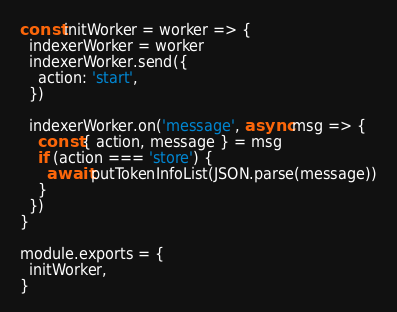Convert code to text. <code><loc_0><loc_0><loc_500><loc_500><_JavaScript_>const initWorker = worker => {
  indexerWorker = worker
  indexerWorker.send({
    action: 'start',
  })

  indexerWorker.on('message', async msg => {
    const { action, message } = msg
    if (action === 'store') {
      await putTokenInfoList(JSON.parse(message))
    }
  })
}

module.exports = {
  initWorker,
}
</code> 